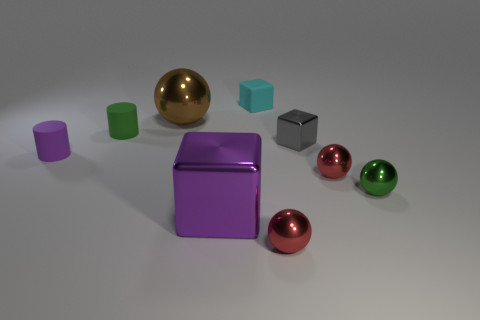Subtract all small blocks. How many blocks are left? 1 Subtract all brown spheres. How many spheres are left? 3 Subtract 1 cylinders. How many cylinders are left? 1 Subtract all big things. Subtract all cyan matte objects. How many objects are left? 6 Add 6 small green matte cylinders. How many small green matte cylinders are left? 7 Add 9 gray metal things. How many gray metal things exist? 10 Subtract 0 red cylinders. How many objects are left? 9 Subtract all spheres. How many objects are left? 5 Subtract all gray cubes. Subtract all blue cylinders. How many cubes are left? 2 Subtract all green blocks. How many yellow cylinders are left? 0 